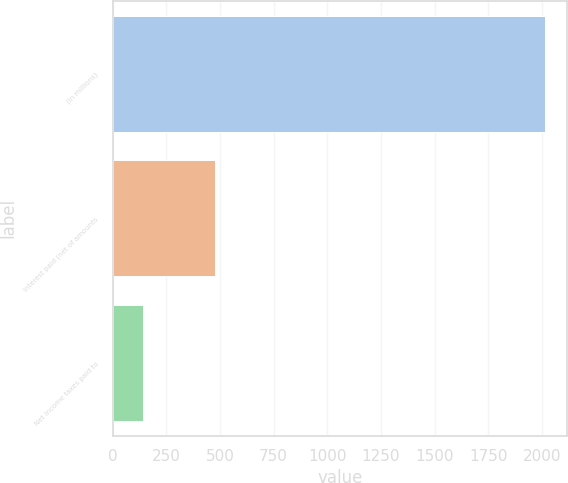Convert chart. <chart><loc_0><loc_0><loc_500><loc_500><bar_chart><fcel>(In millions)<fcel>Interest paid (net of amounts<fcel>Net income taxes paid to<nl><fcel>2016<fcel>478<fcel>140<nl></chart> 